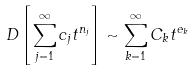<formula> <loc_0><loc_0><loc_500><loc_500>D \left [ \sum _ { j = 1 } ^ { \infty } c _ { j } t ^ { n _ { j } } \right ] \sim \sum _ { k = 1 } ^ { \infty } C _ { k } t ^ { e _ { k } }</formula> 